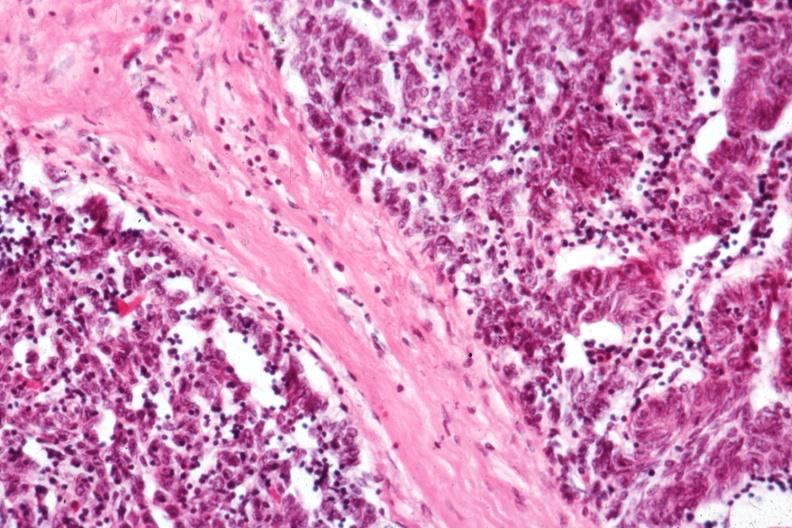does opened base of skull with brain show predominant epithelial component?
Answer the question using a single word or phrase. No 